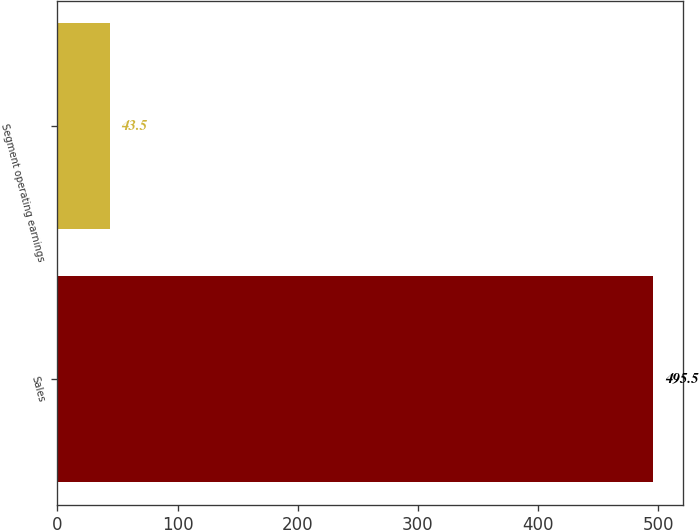Convert chart. <chart><loc_0><loc_0><loc_500><loc_500><bar_chart><fcel>Sales<fcel>Segment operating earnings<nl><fcel>495.5<fcel>43.5<nl></chart> 